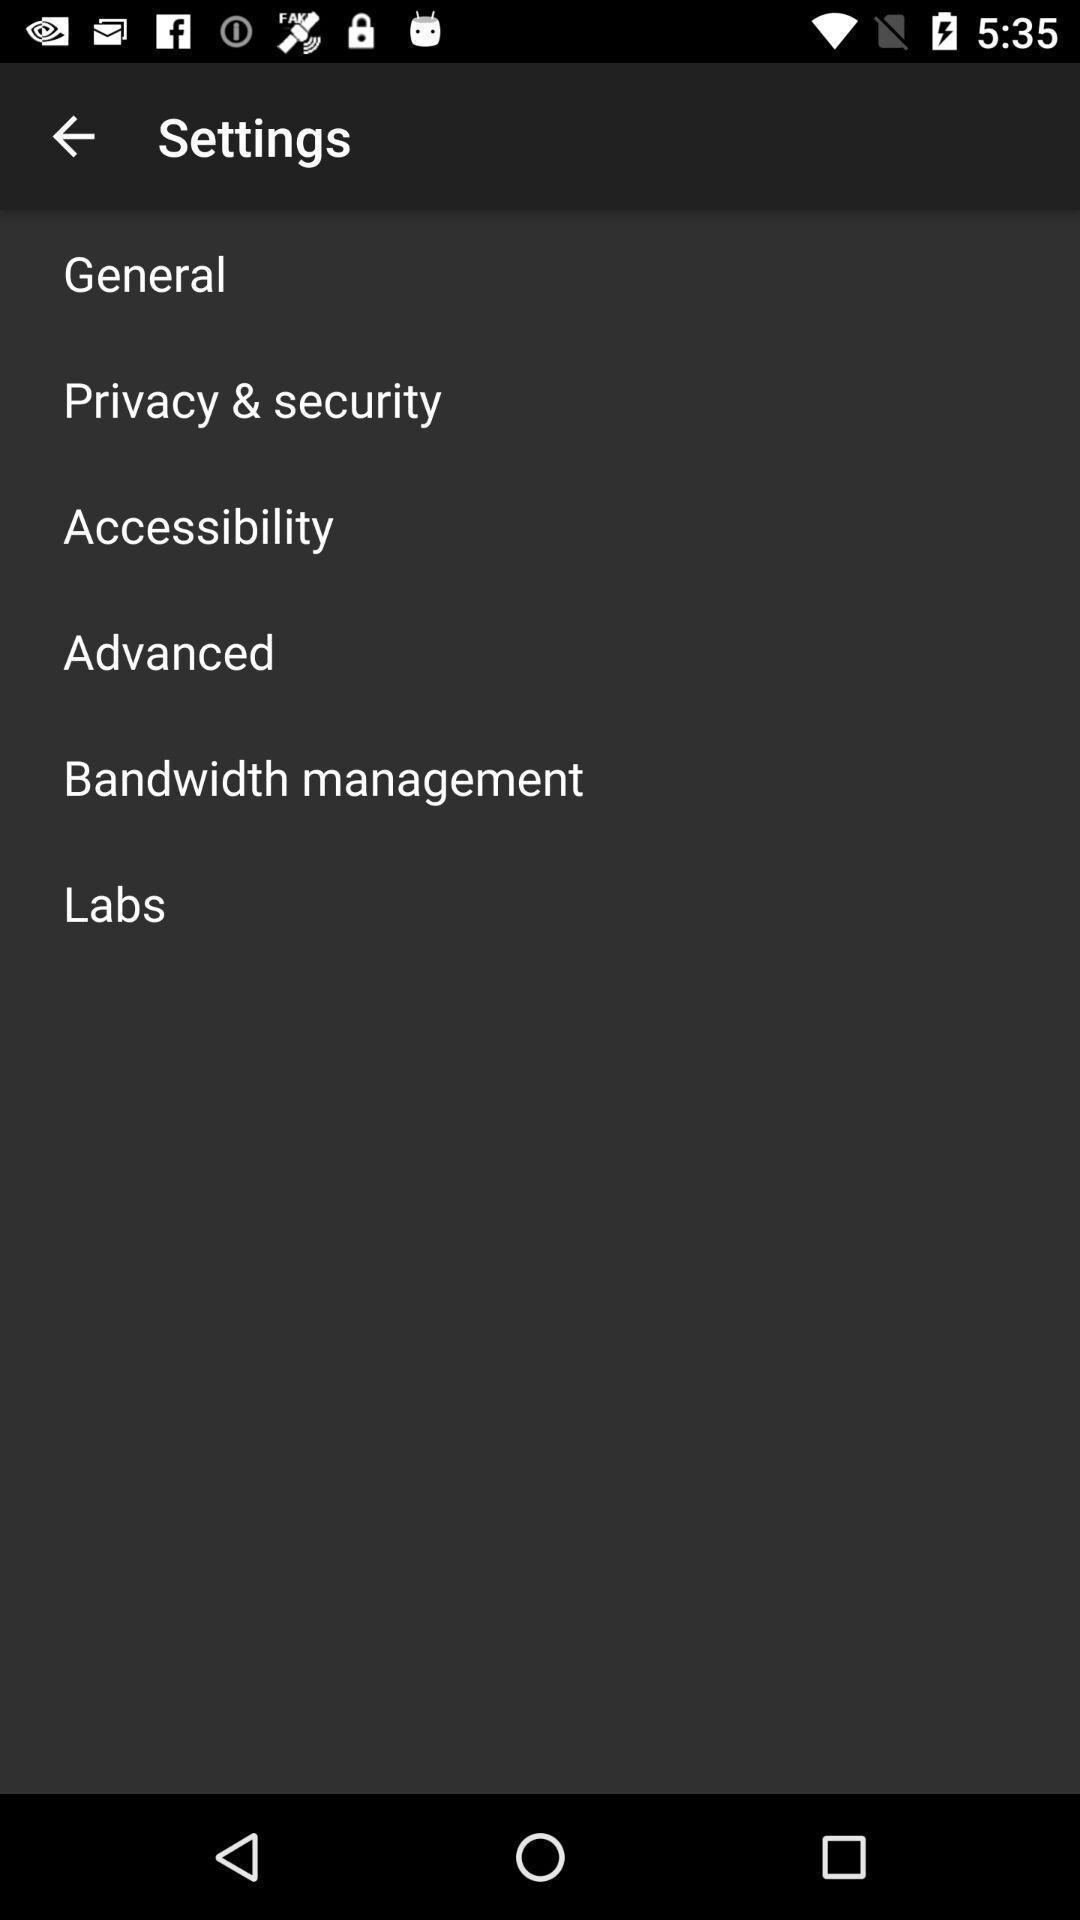Explain the elements present in this screenshot. Setting page displaying the various options. 